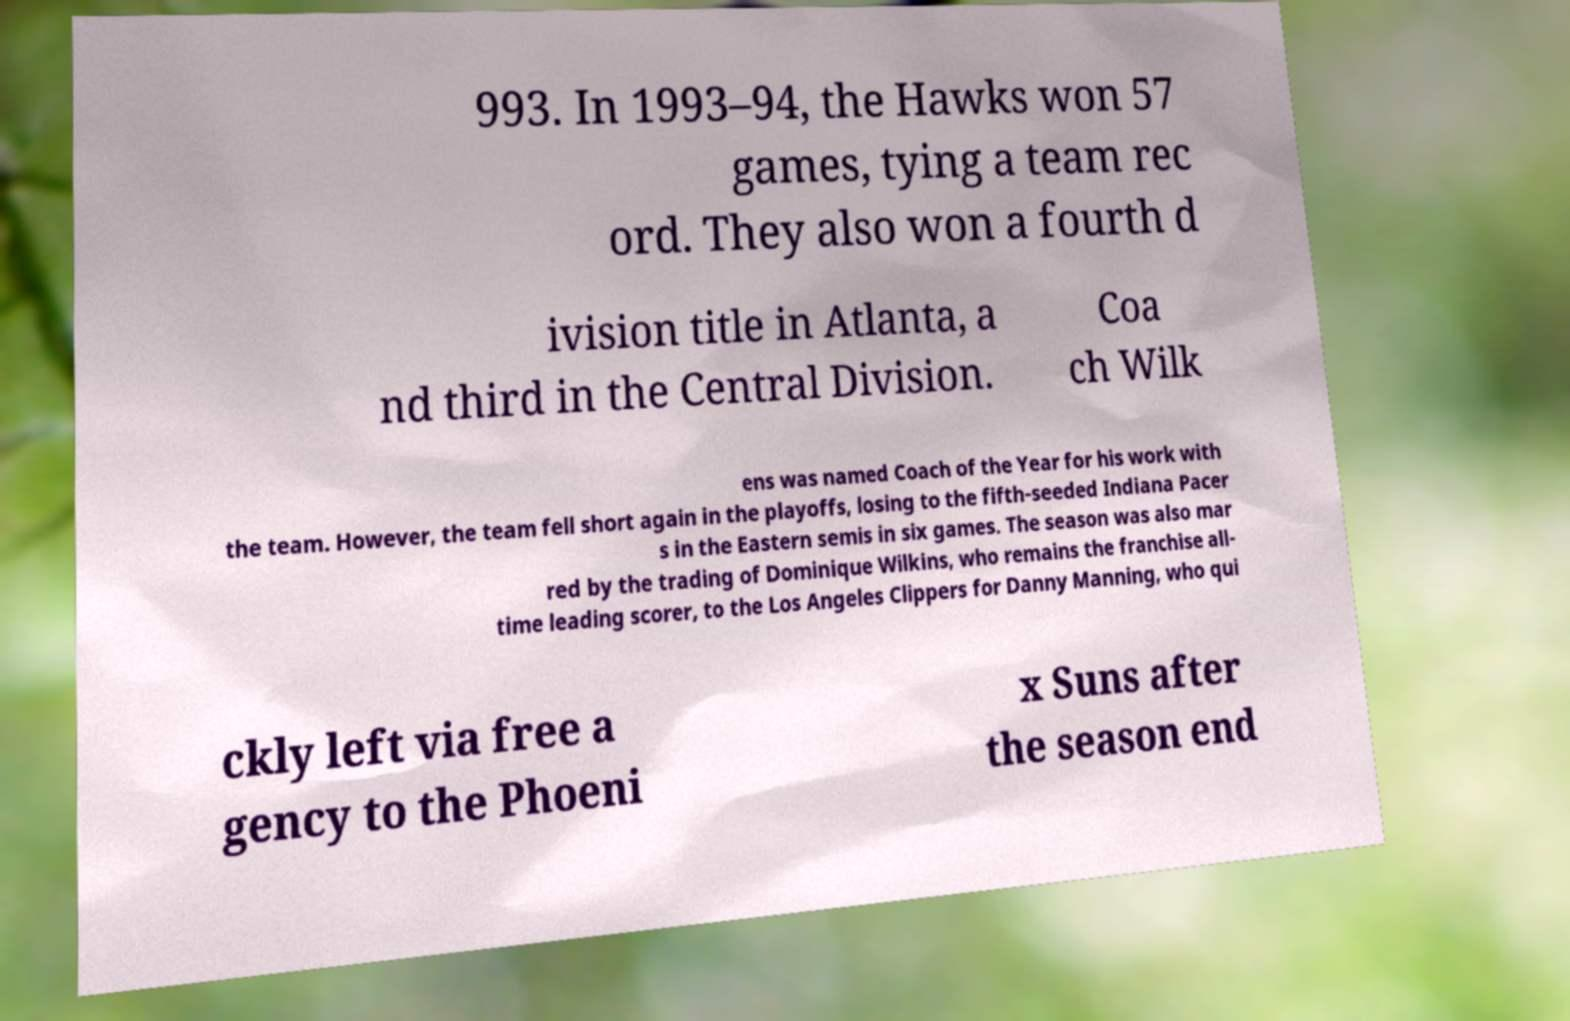Can you read and provide the text displayed in the image?This photo seems to have some interesting text. Can you extract and type it out for me? 993. In 1993–94, the Hawks won 57 games, tying a team rec ord. They also won a fourth d ivision title in Atlanta, a nd third in the Central Division. Coa ch Wilk ens was named Coach of the Year for his work with the team. However, the team fell short again in the playoffs, losing to the fifth-seeded Indiana Pacer s in the Eastern semis in six games. The season was also mar red by the trading of Dominique Wilkins, who remains the franchise all- time leading scorer, to the Los Angeles Clippers for Danny Manning, who qui ckly left via free a gency to the Phoeni x Suns after the season end 